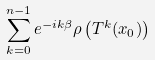<formula> <loc_0><loc_0><loc_500><loc_500>\sum _ { k = 0 } ^ { n - 1 } e ^ { - i k \beta } \rho \left ( T ^ { k } ( x _ { 0 } ) \right )</formula> 